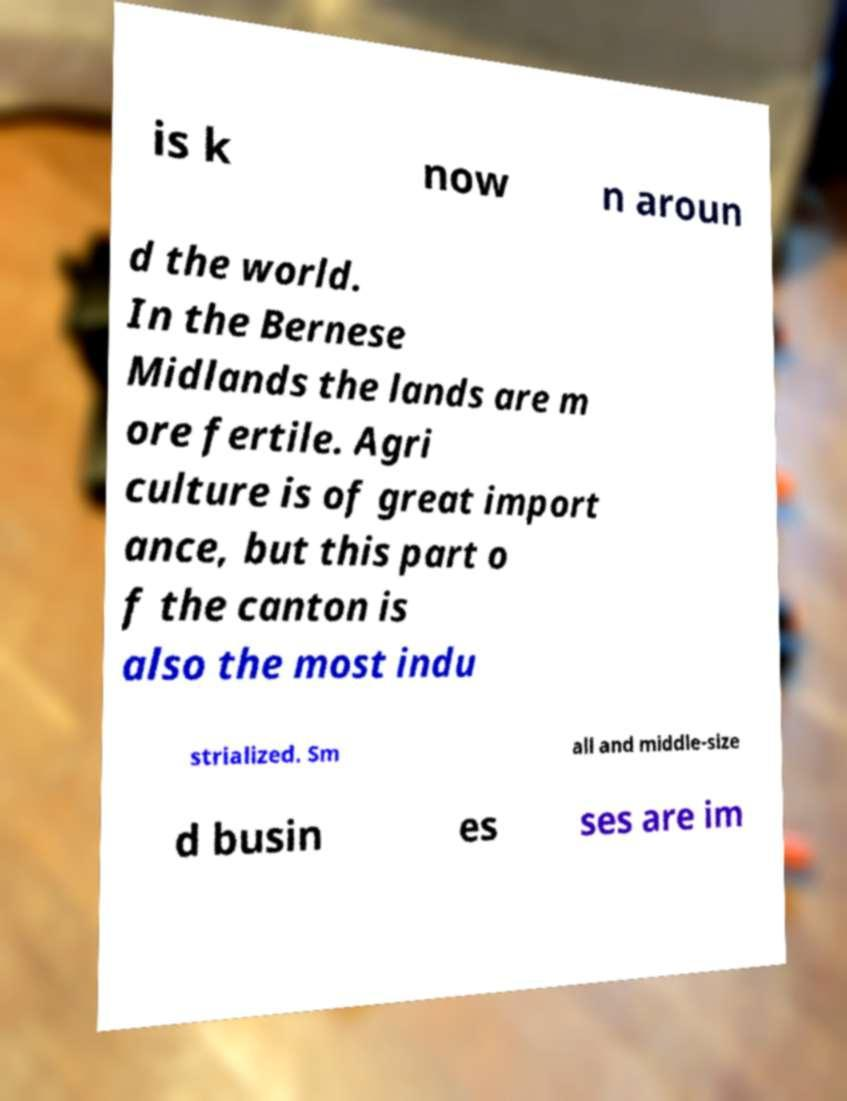Please identify and transcribe the text found in this image. is k now n aroun d the world. In the Bernese Midlands the lands are m ore fertile. Agri culture is of great import ance, but this part o f the canton is also the most indu strialized. Sm all and middle-size d busin es ses are im 